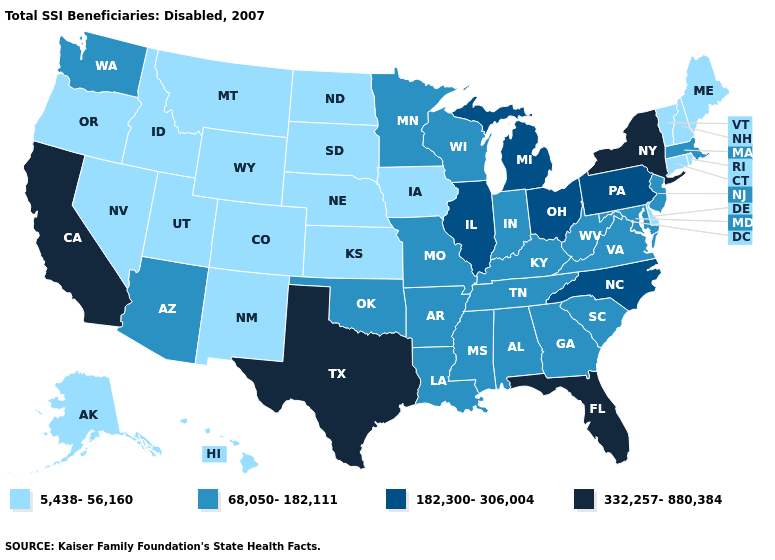Does Texas have the lowest value in the USA?
Concise answer only. No. What is the value of Iowa?
Be succinct. 5,438-56,160. Does Illinois have the highest value in the MidWest?
Give a very brief answer. Yes. Does the first symbol in the legend represent the smallest category?
Write a very short answer. Yes. What is the highest value in states that border New York?
Write a very short answer. 182,300-306,004. Does the map have missing data?
Quick response, please. No. What is the value of South Dakota?
Write a very short answer. 5,438-56,160. Which states have the highest value in the USA?
Short answer required. California, Florida, New York, Texas. Does Illinois have the same value as Idaho?
Quick response, please. No. What is the lowest value in the USA?
Keep it brief. 5,438-56,160. Name the states that have a value in the range 182,300-306,004?
Be succinct. Illinois, Michigan, North Carolina, Ohio, Pennsylvania. Does the map have missing data?
Be succinct. No. Is the legend a continuous bar?
Quick response, please. No. Among the states that border Ohio , which have the highest value?
Quick response, please. Michigan, Pennsylvania. 